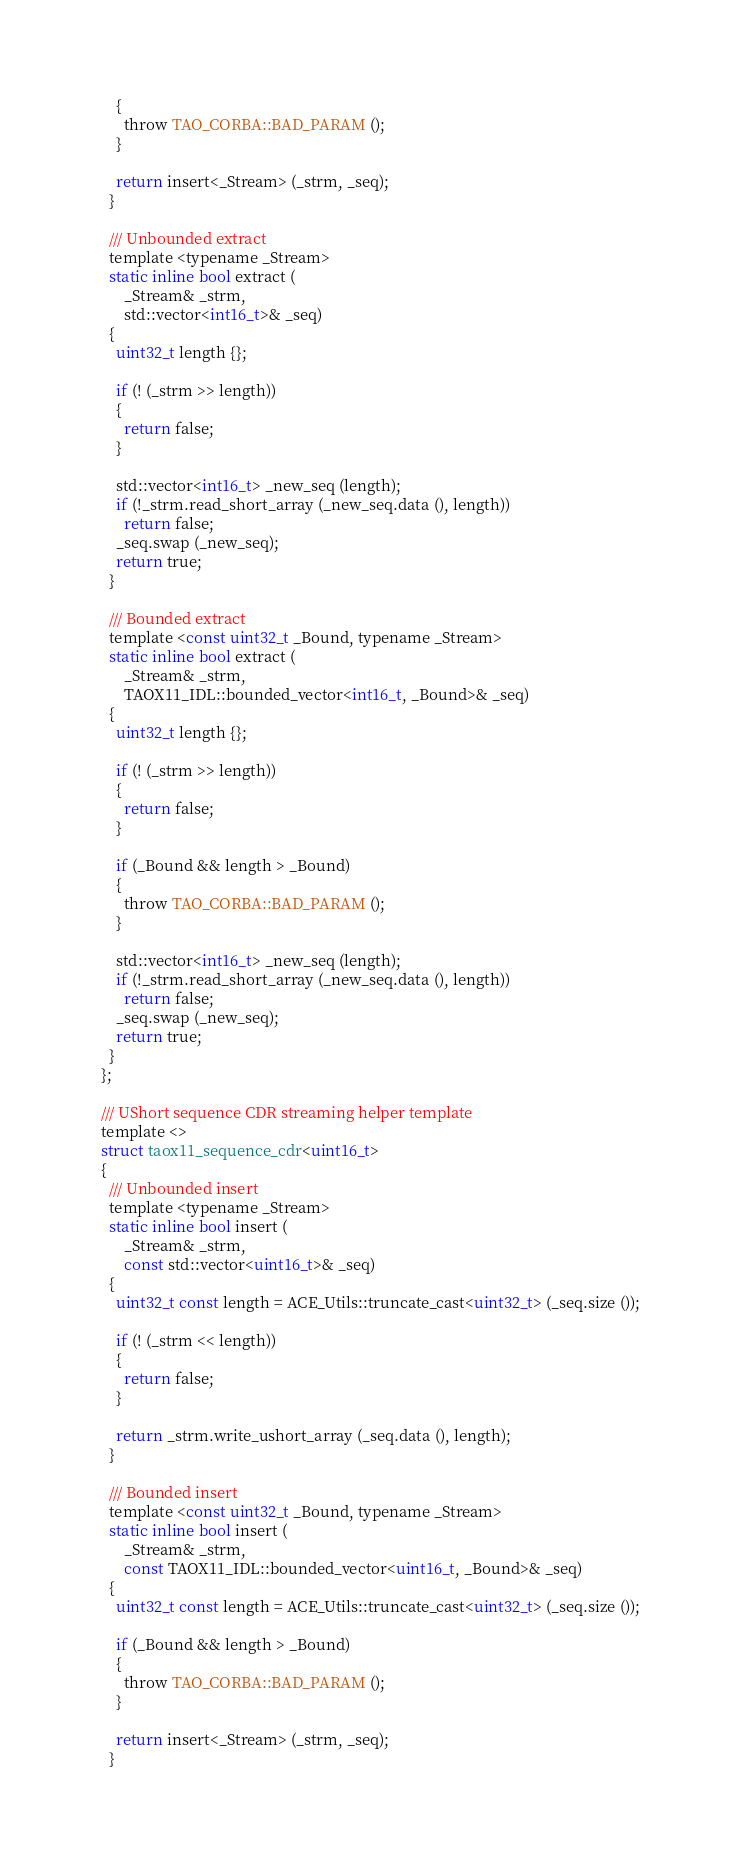<code> <loc_0><loc_0><loc_500><loc_500><_C_>      {
        throw TAO_CORBA::BAD_PARAM ();
      }

      return insert<_Stream> (_strm, _seq);
    }

    /// Unbounded extract
    template <typename _Stream>
    static inline bool extract (
        _Stream& _strm,
        std::vector<int16_t>& _seq)
    {
      uint32_t length {};

      if (! (_strm >> length))
      {
        return false;
      }

      std::vector<int16_t> _new_seq (length);
      if (!_strm.read_short_array (_new_seq.data (), length))
        return false;
      _seq.swap (_new_seq);
      return true;
    }

    /// Bounded extract
    template <const uint32_t _Bound, typename _Stream>
    static inline bool extract (
        _Stream& _strm,
        TAOX11_IDL::bounded_vector<int16_t, _Bound>& _seq)
    {
      uint32_t length {};

      if (! (_strm >> length))
      {
        return false;
      }

      if (_Bound && length > _Bound)
      {
        throw TAO_CORBA::BAD_PARAM ();
      }

      std::vector<int16_t> _new_seq (length);
      if (!_strm.read_short_array (_new_seq.data (), length))
        return false;
      _seq.swap (_new_seq);
      return true;
    }
  };

  /// UShort sequence CDR streaming helper template
  template <>
  struct taox11_sequence_cdr<uint16_t>
  {
    /// Unbounded insert
    template <typename _Stream>
    static inline bool insert (
        _Stream& _strm,
        const std::vector<uint16_t>& _seq)
    {
      uint32_t const length = ACE_Utils::truncate_cast<uint32_t> (_seq.size ());

      if (! (_strm << length))
      {
        return false;
      }

      return _strm.write_ushort_array (_seq.data (), length);
    }

    /// Bounded insert
    template <const uint32_t _Bound, typename _Stream>
    static inline bool insert (
        _Stream& _strm,
        const TAOX11_IDL::bounded_vector<uint16_t, _Bound>& _seq)
    {
      uint32_t const length = ACE_Utils::truncate_cast<uint32_t> (_seq.size ());

      if (_Bound && length > _Bound)
      {
        throw TAO_CORBA::BAD_PARAM ();
      }

      return insert<_Stream> (_strm, _seq);
    }
</code> 